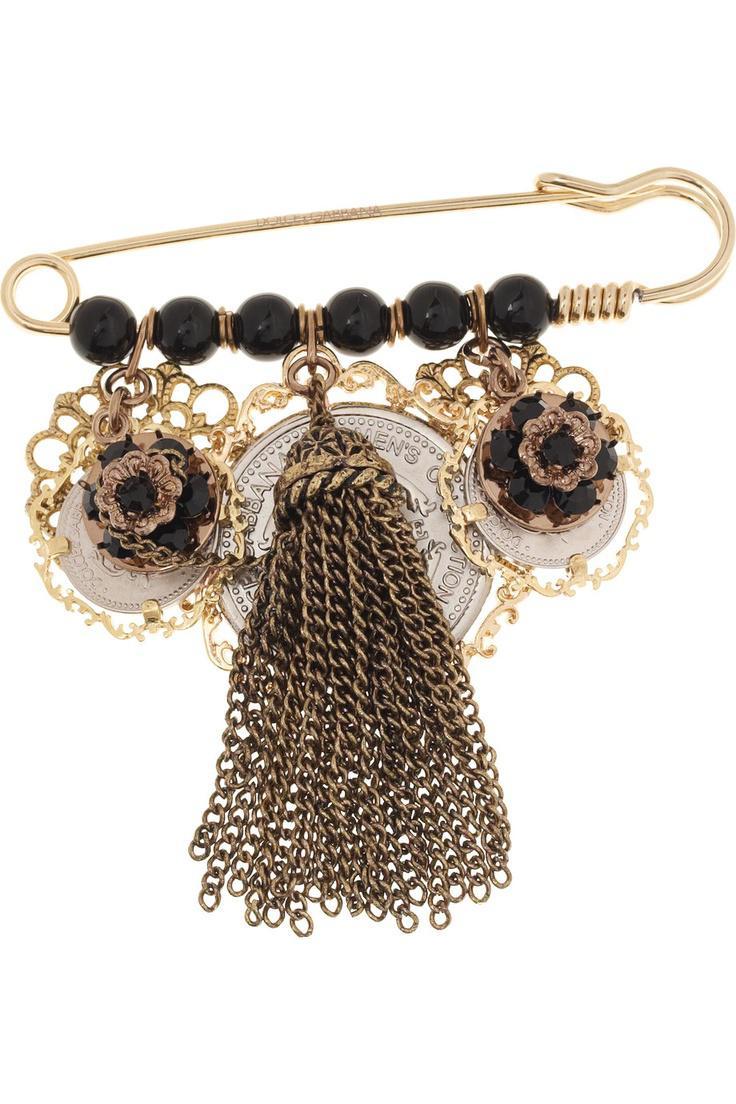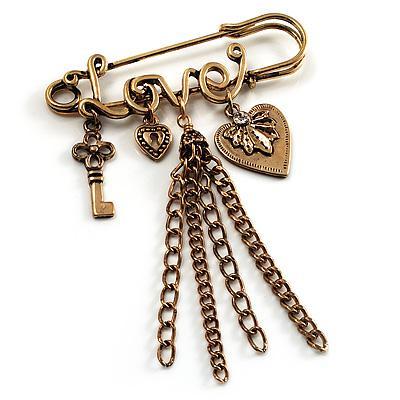The first image is the image on the left, the second image is the image on the right. Considering the images on both sides, is "The pin on the left is strung with six beads, and the pin on the right features gold letter shapes." valid? Answer yes or no. Yes. The first image is the image on the left, the second image is the image on the right. Assess this claim about the two images: "there is a pin with at least one charm being a key". Correct or not? Answer yes or no. Yes. 